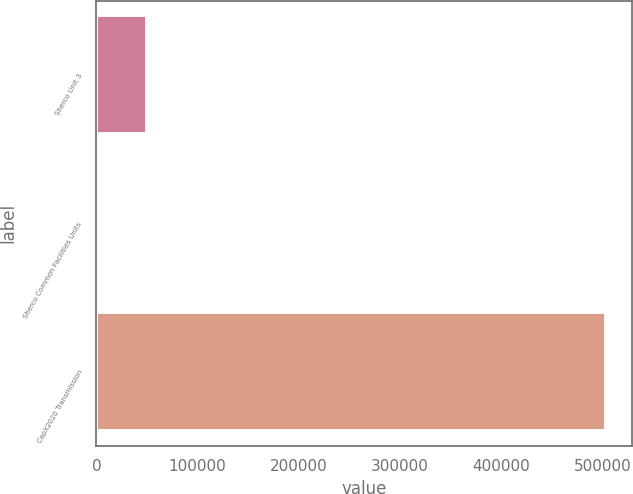<chart> <loc_0><loc_0><loc_500><loc_500><bar_chart><fcel>Sherco Unit 3<fcel>Sherco Common Facilities Units<fcel>CapX2020 Transmission<nl><fcel>50426.3<fcel>61<fcel>503714<nl></chart> 